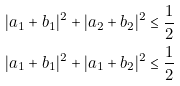Convert formula to latex. <formula><loc_0><loc_0><loc_500><loc_500>| a _ { 1 } + b _ { 1 } | ^ { 2 } + | a _ { 2 } + b _ { 2 } | ^ { 2 } & \leq \frac { 1 } { 2 } \\ | a _ { 1 } + b _ { 1 } | ^ { 2 } + | a _ { 1 } + b _ { 2 } | ^ { 2 } & \leq \frac { 1 } { 2 }</formula> 